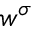Convert formula to latex. <formula><loc_0><loc_0><loc_500><loc_500>w ^ { \sigma }</formula> 